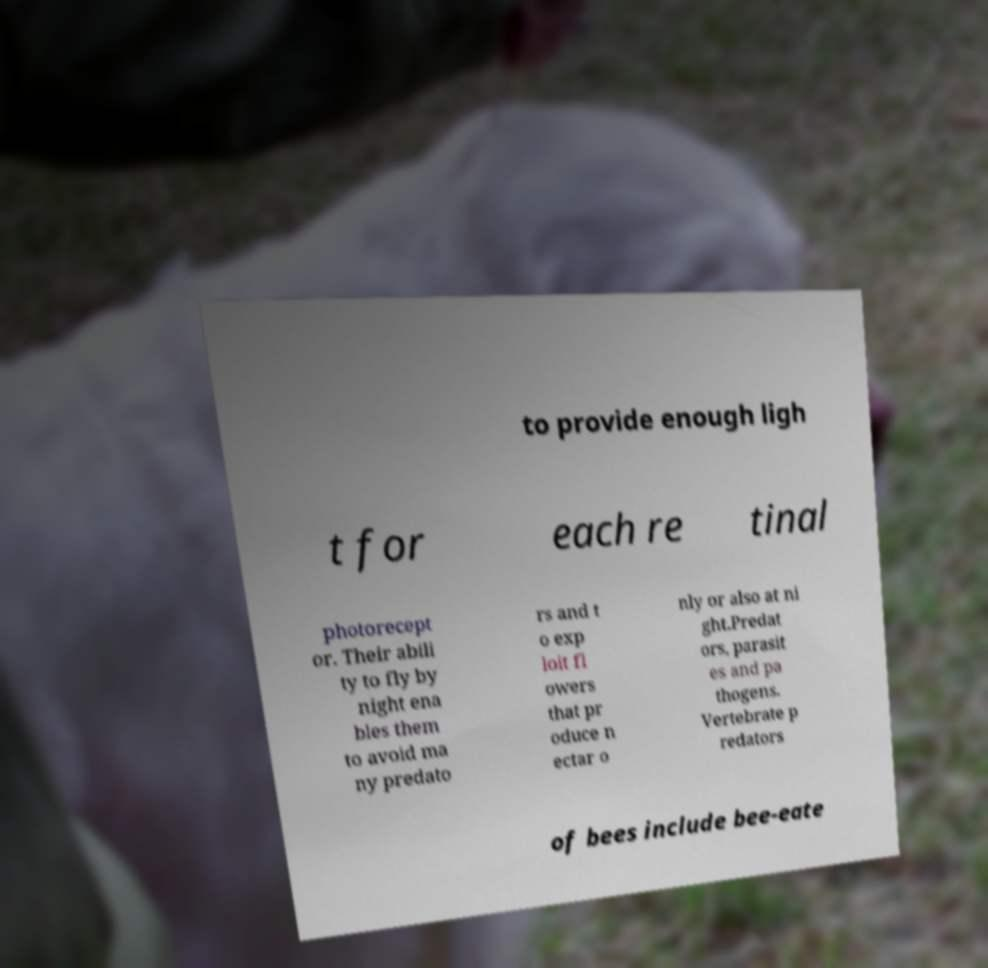Could you assist in decoding the text presented in this image and type it out clearly? to provide enough ligh t for each re tinal photorecept or. Their abili ty to fly by night ena bles them to avoid ma ny predato rs and t o exp loit fl owers that pr oduce n ectar o nly or also at ni ght.Predat ors, parasit es and pa thogens. Vertebrate p redators of bees include bee-eate 